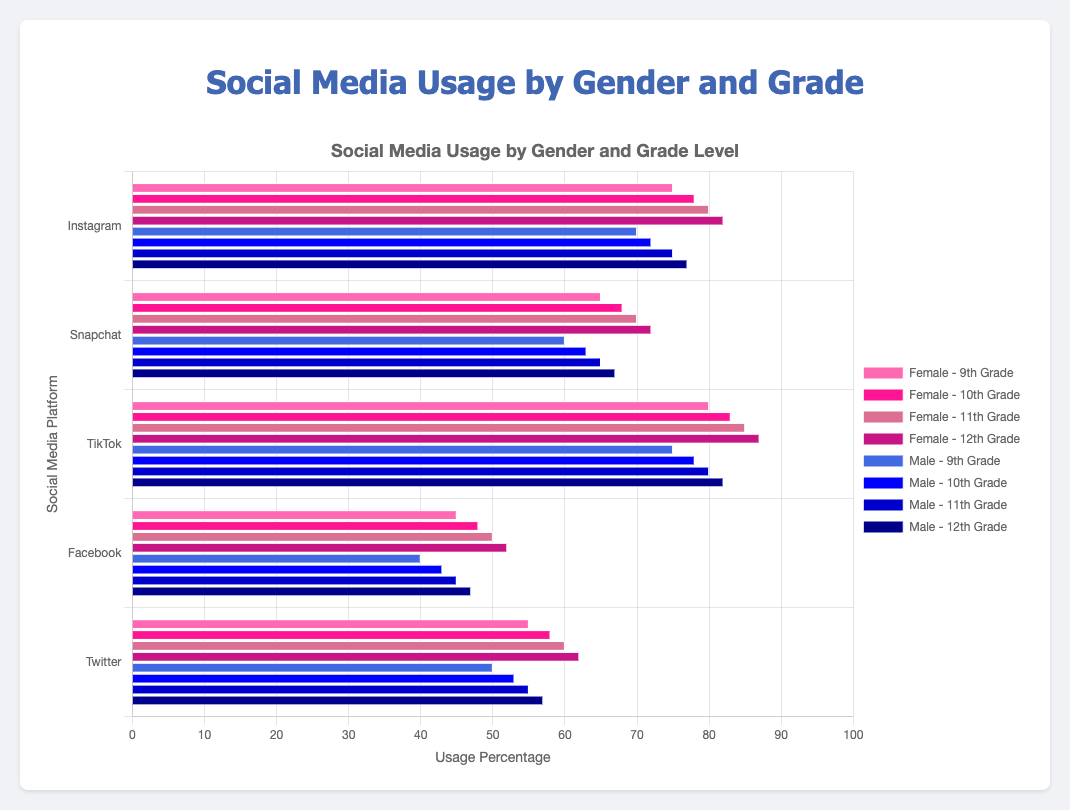What is the percentage of 11th-grade males using TikTok? Look at the bar for TikTok under the category of 11th-grade males. The height of the bar indicates the percentage.
Answer: 80% How does the usage of Instagram compare between 9th-grade females and males? Compare the bars for 9th-grade females and males under the Instagram category. 9th-grade females have 75% usage, while 9th-grade males have 70% usage.
Answer: Females use it 5% more Which social media platform has the highest overall usage for 12th-grade females? Scan the bars for 12th-grade females across all social media platforms and identify the highest bar. TikTok has the highest value at 87%.
Answer: TikTok What is the difference in Snapchat usage between 10th-grade females and 12th-grade males? Look at the usage values for 10th-grade females (68%) and 12th-grade males (67%) in the Snapchat category, then find the difference.
Answer: 1% Which gender has a higher average usage percentage across all platforms in 11th grade? Calculate the average usage percentage for each gender in 11th grade: Females (80 + 70 + 85 + 50 + 60) / 5 = 69, Males (75 + 65 + 80 + 45 + 55) / 5 = 64.
Answer: Females What is the total usage percentage of Facebook by males across all grade levels? Sum up the Facebook usage percentages for males from 9th to 12th grade: 40% + 43% + 45% + 47%.
Answer: 175% Which platform has the smallest difference in usage between 9th-grade females and 9th-grade males? Calculate the differences for each platform between 9th-grade females and males: Instagram (75-70=5), Snapchat (65-60=5), TikTok (80-75=5), Facebook (45-40=5), Twitter (55-50=5). All differences are 5%.
Answer: All platforms have the same difference Is the usage of Twitter higher for 12th-grade females or 10th-grade males? Compare the values for Twitter usage between 12th-grade females (62%) and 10th-grade males (53%).
Answer: 12th-grade females For 11th-grade students, which social media platform has a more significant difference in usage between genders? Calculate the differences in usage between genders for 11th graders: Instagram (80-75=5), Snapchat (70-65=5), TikTok (85-80=5), Facebook (50-45=5), Twitter (60-55=5). All differences are 5%.
Answer: All platforms have the same difference What’s the average usage percentage of TikTok for females across all grades? Sum up the TikTok usage percentages for females across all grades and divide by 4: (80 + 83 + 85 + 87) / 4.
Answer: 83.75% 